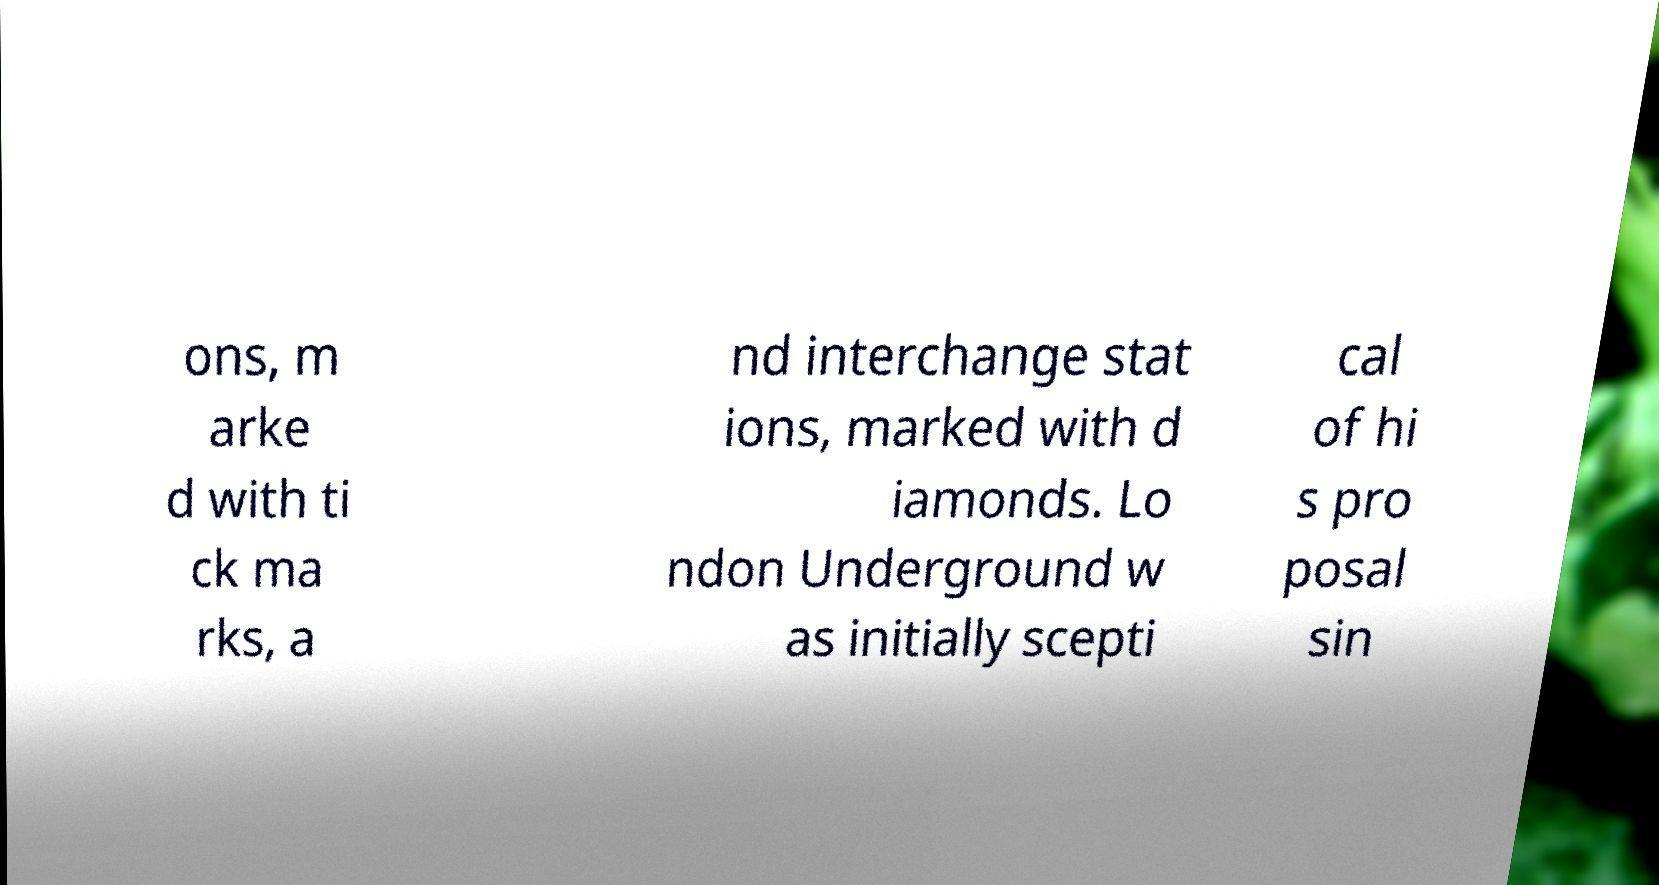Please identify and transcribe the text found in this image. ons, m arke d with ti ck ma rks, a nd interchange stat ions, marked with d iamonds. Lo ndon Underground w as initially scepti cal of hi s pro posal sin 